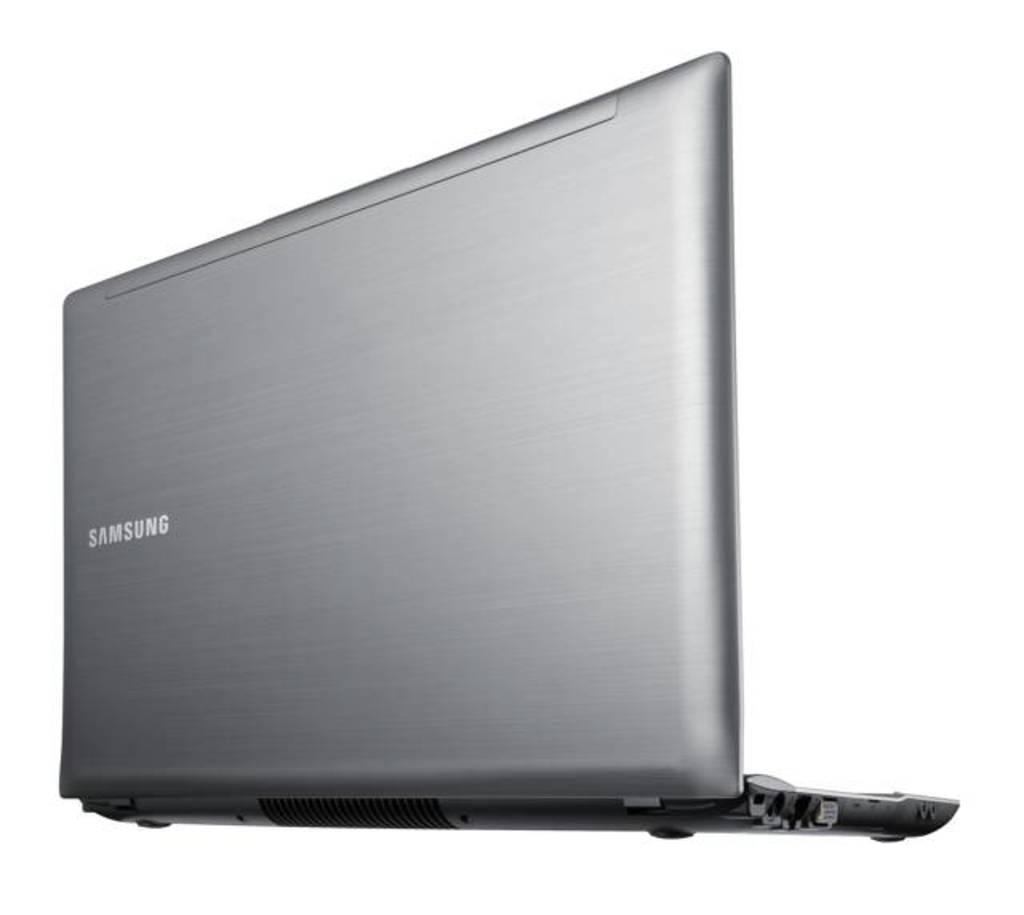<image>
Offer a succinct explanation of the picture presented. A silver Samsung laptop has it's lid in an open position. 